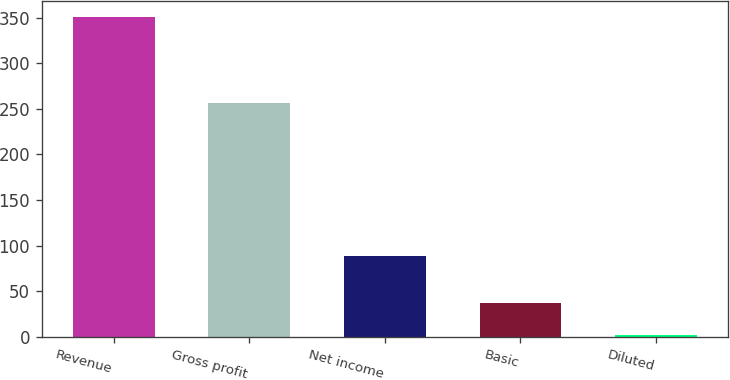Convert chart to OTSL. <chart><loc_0><loc_0><loc_500><loc_500><bar_chart><fcel>Revenue<fcel>Gross profit<fcel>Net income<fcel>Basic<fcel>Diluted<nl><fcel>350.7<fcel>256.8<fcel>88.7<fcel>37.04<fcel>2.19<nl></chart> 